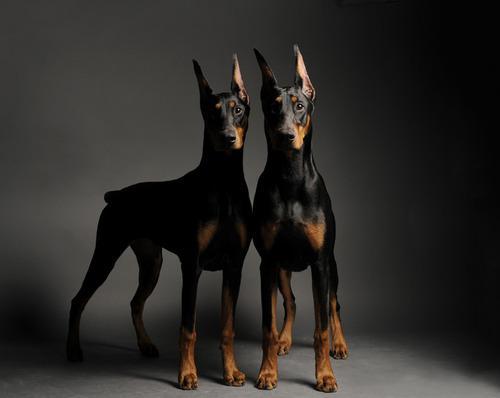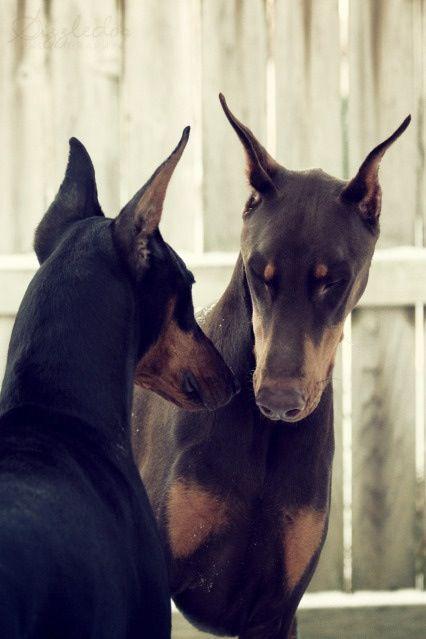The first image is the image on the left, the second image is the image on the right. Analyze the images presented: Is the assertion "A dog in one of the images is solid white, and one dog has a very visible collar." valid? Answer yes or no. No. 